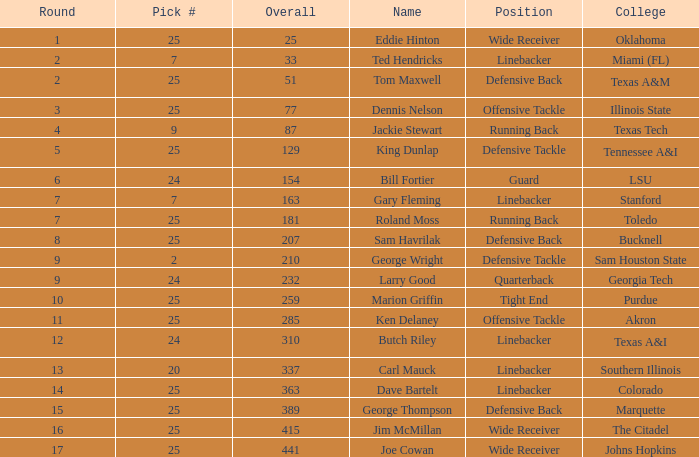Round larger than 6, and a Pick # smaller than 25, and a College of southern Illinois has what position? Linebacker. 